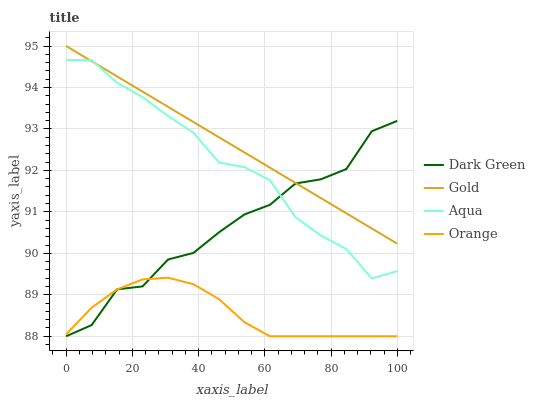Does Orange have the minimum area under the curve?
Answer yes or no. Yes. Does Gold have the maximum area under the curve?
Answer yes or no. Yes. Does Aqua have the minimum area under the curve?
Answer yes or no. No. Does Aqua have the maximum area under the curve?
Answer yes or no. No. Is Gold the smoothest?
Answer yes or no. Yes. Is Dark Green the roughest?
Answer yes or no. Yes. Is Aqua the smoothest?
Answer yes or no. No. Is Aqua the roughest?
Answer yes or no. No. Does Orange have the lowest value?
Answer yes or no. Yes. Does Aqua have the lowest value?
Answer yes or no. No. Does Gold have the highest value?
Answer yes or no. Yes. Does Aqua have the highest value?
Answer yes or no. No. Is Orange less than Aqua?
Answer yes or no. Yes. Is Gold greater than Orange?
Answer yes or no. Yes. Does Dark Green intersect Orange?
Answer yes or no. Yes. Is Dark Green less than Orange?
Answer yes or no. No. Is Dark Green greater than Orange?
Answer yes or no. No. Does Orange intersect Aqua?
Answer yes or no. No. 